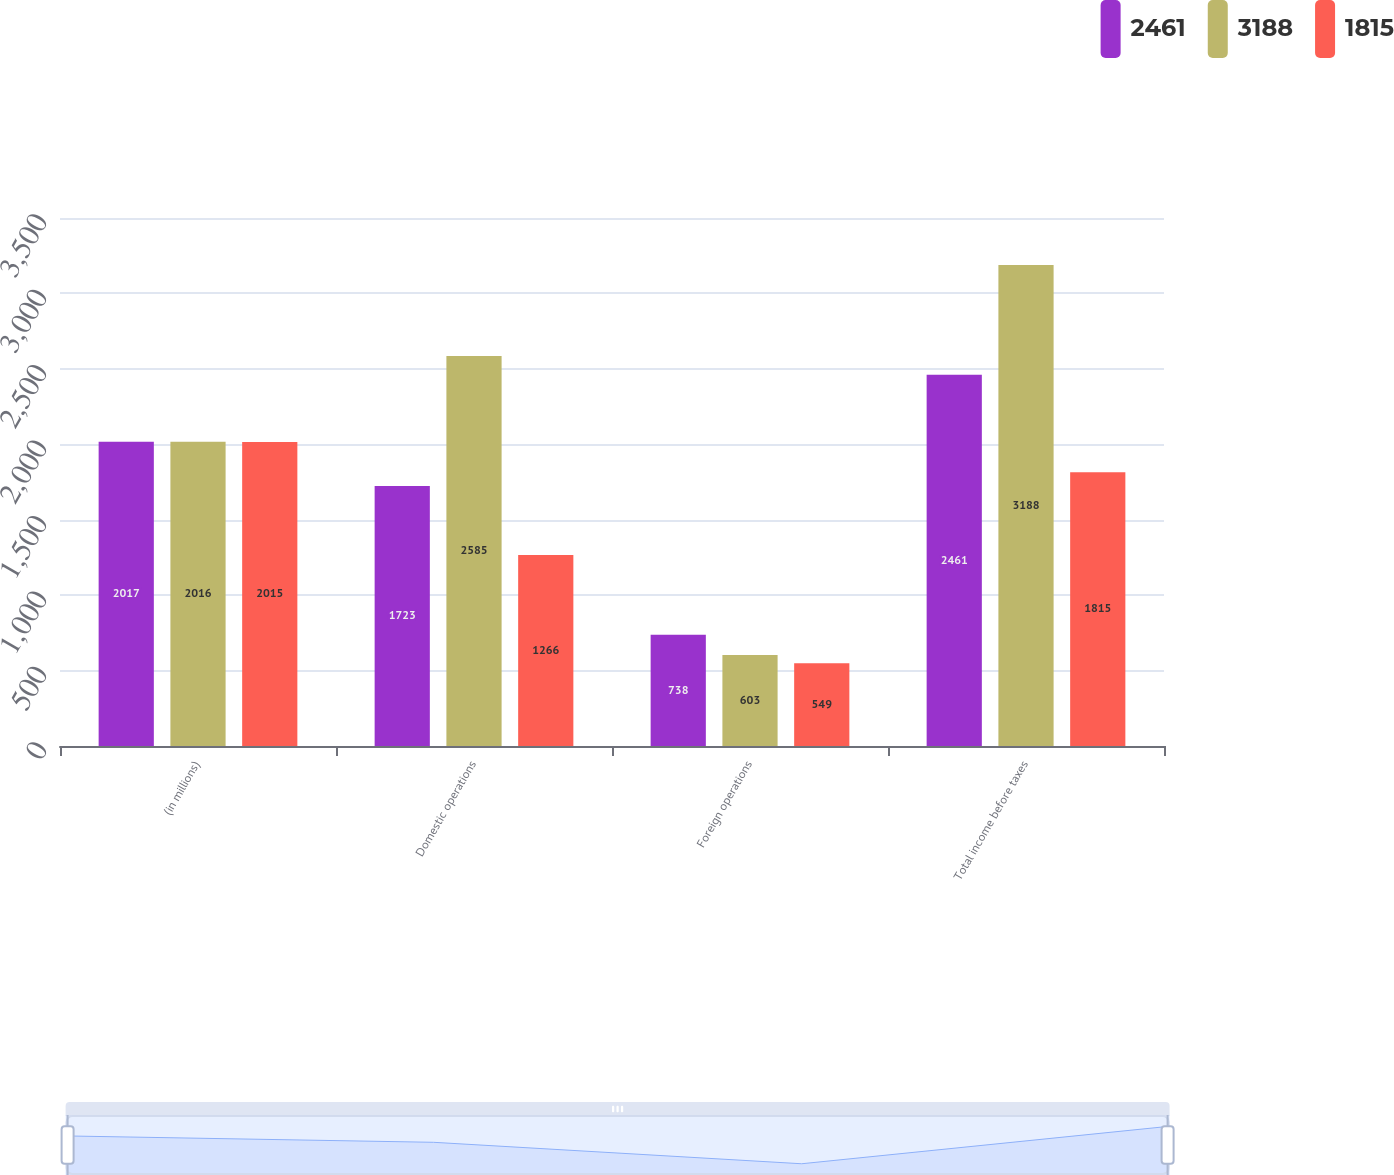Convert chart to OTSL. <chart><loc_0><loc_0><loc_500><loc_500><stacked_bar_chart><ecel><fcel>(in millions)<fcel>Domestic operations<fcel>Foreign operations<fcel>Total income before taxes<nl><fcel>2461<fcel>2017<fcel>1723<fcel>738<fcel>2461<nl><fcel>3188<fcel>2016<fcel>2585<fcel>603<fcel>3188<nl><fcel>1815<fcel>2015<fcel>1266<fcel>549<fcel>1815<nl></chart> 